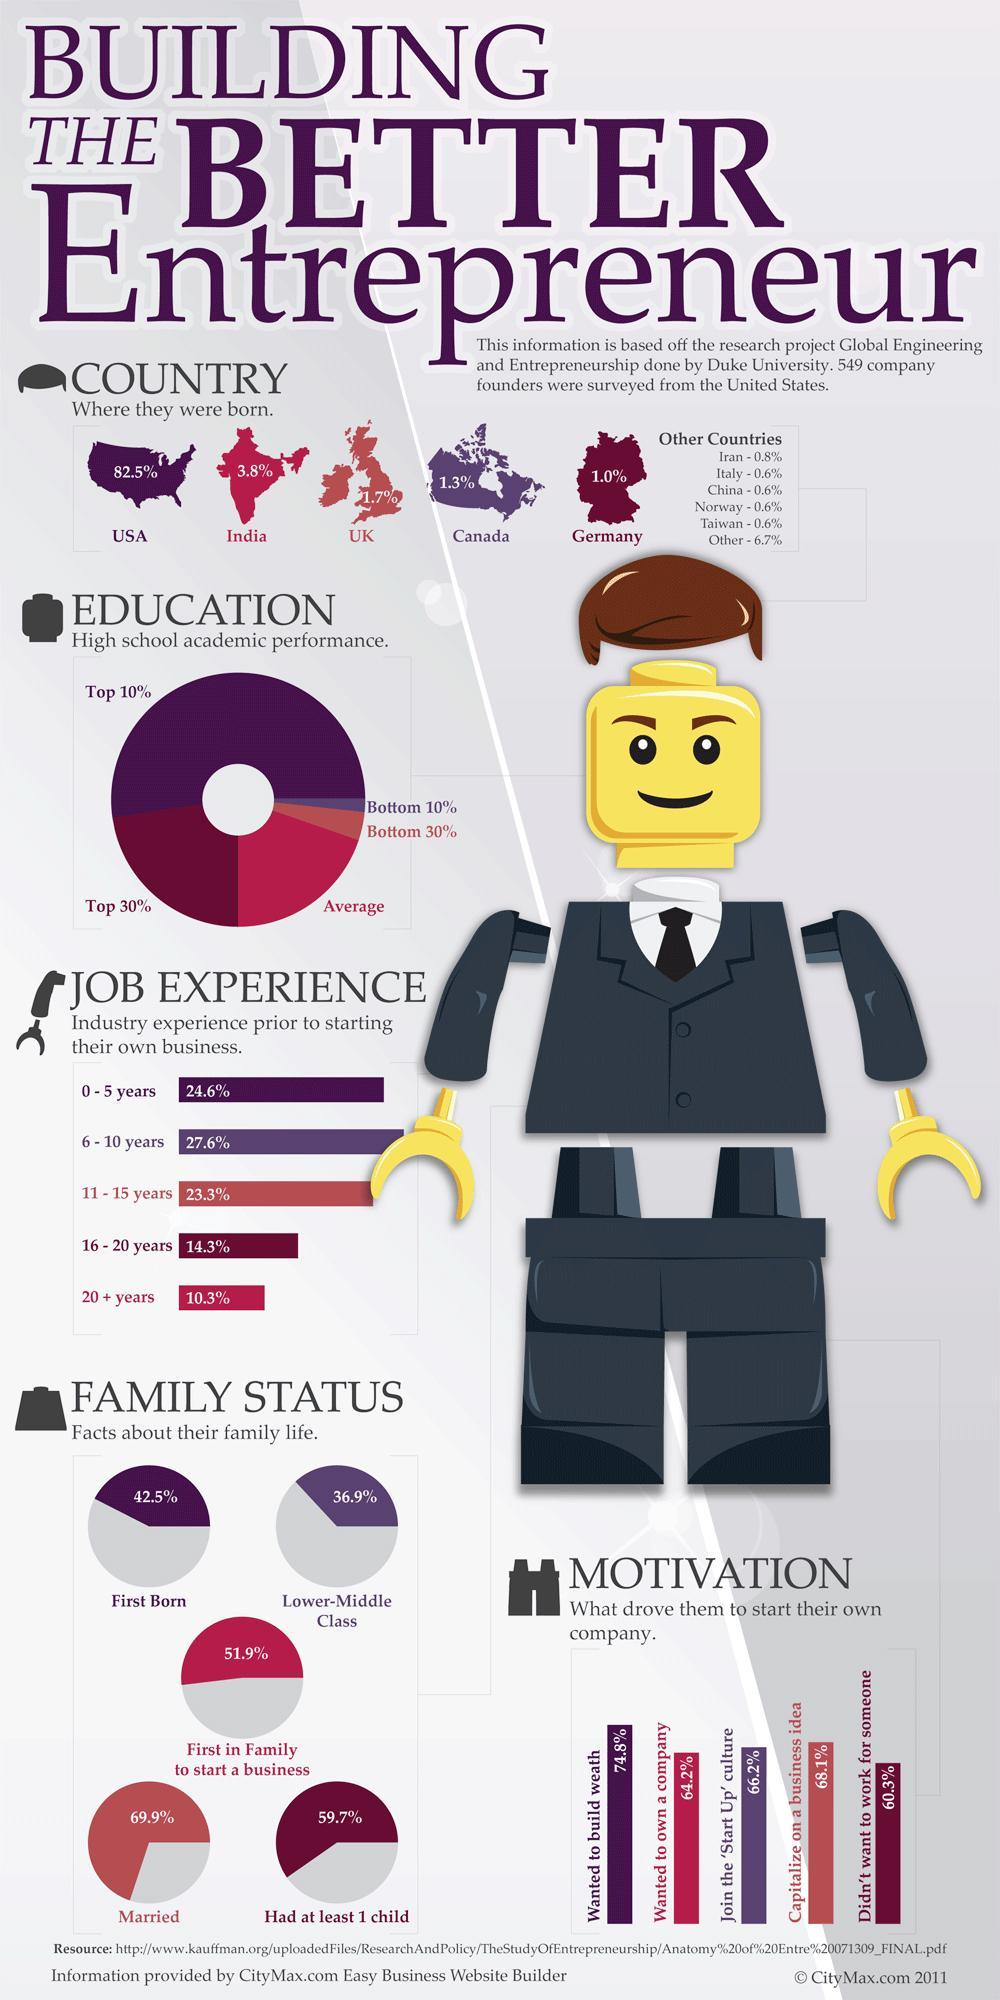What percentage of founders capitalized on a business idea
Answer the question with a short phrase. 68.1% What is the total % of founders born in other countries 9.9 How many founders were the first in family to start a business 51.9% what percentage of founders were born in India 3.8% What was the total % of founders with job expereince of 16-20+ years 24.6 